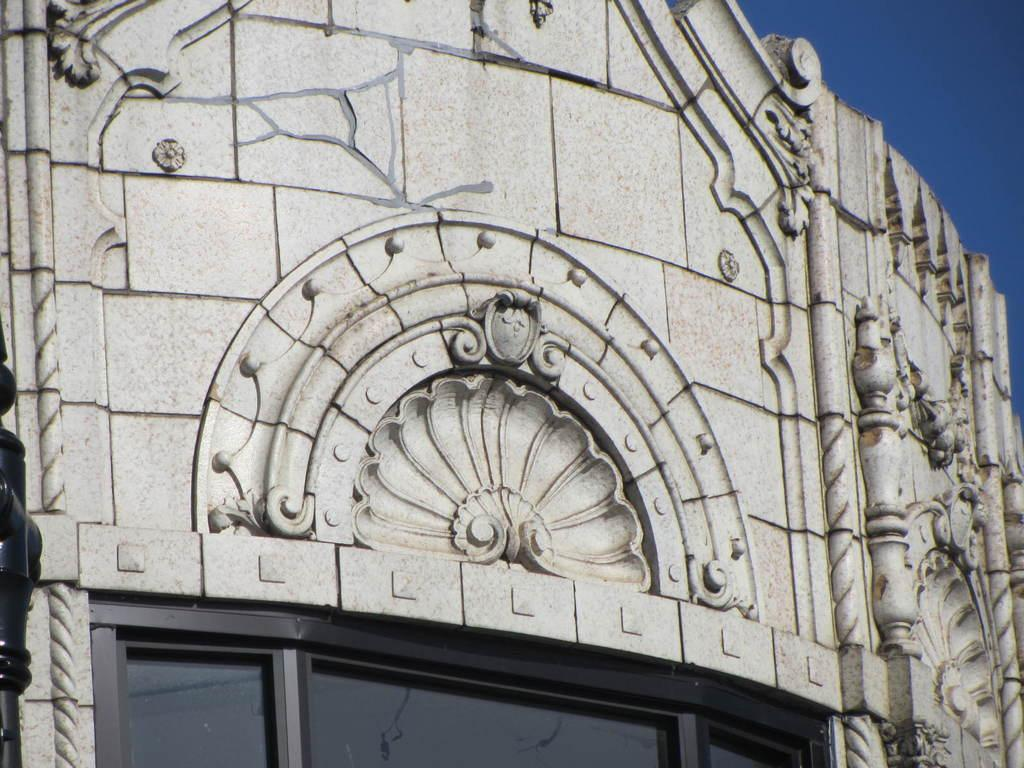What is the main subject of the image? The main subject of the image is a building. Can you describe any specific features of the building? Yes, the building has sculptures on it. What is visible at the top of the image? The sky is visible at the top of the image. How many afterthoughts are present in the image? There are no afterthoughts present in the image, as it is a photograph of a building with sculptures. 